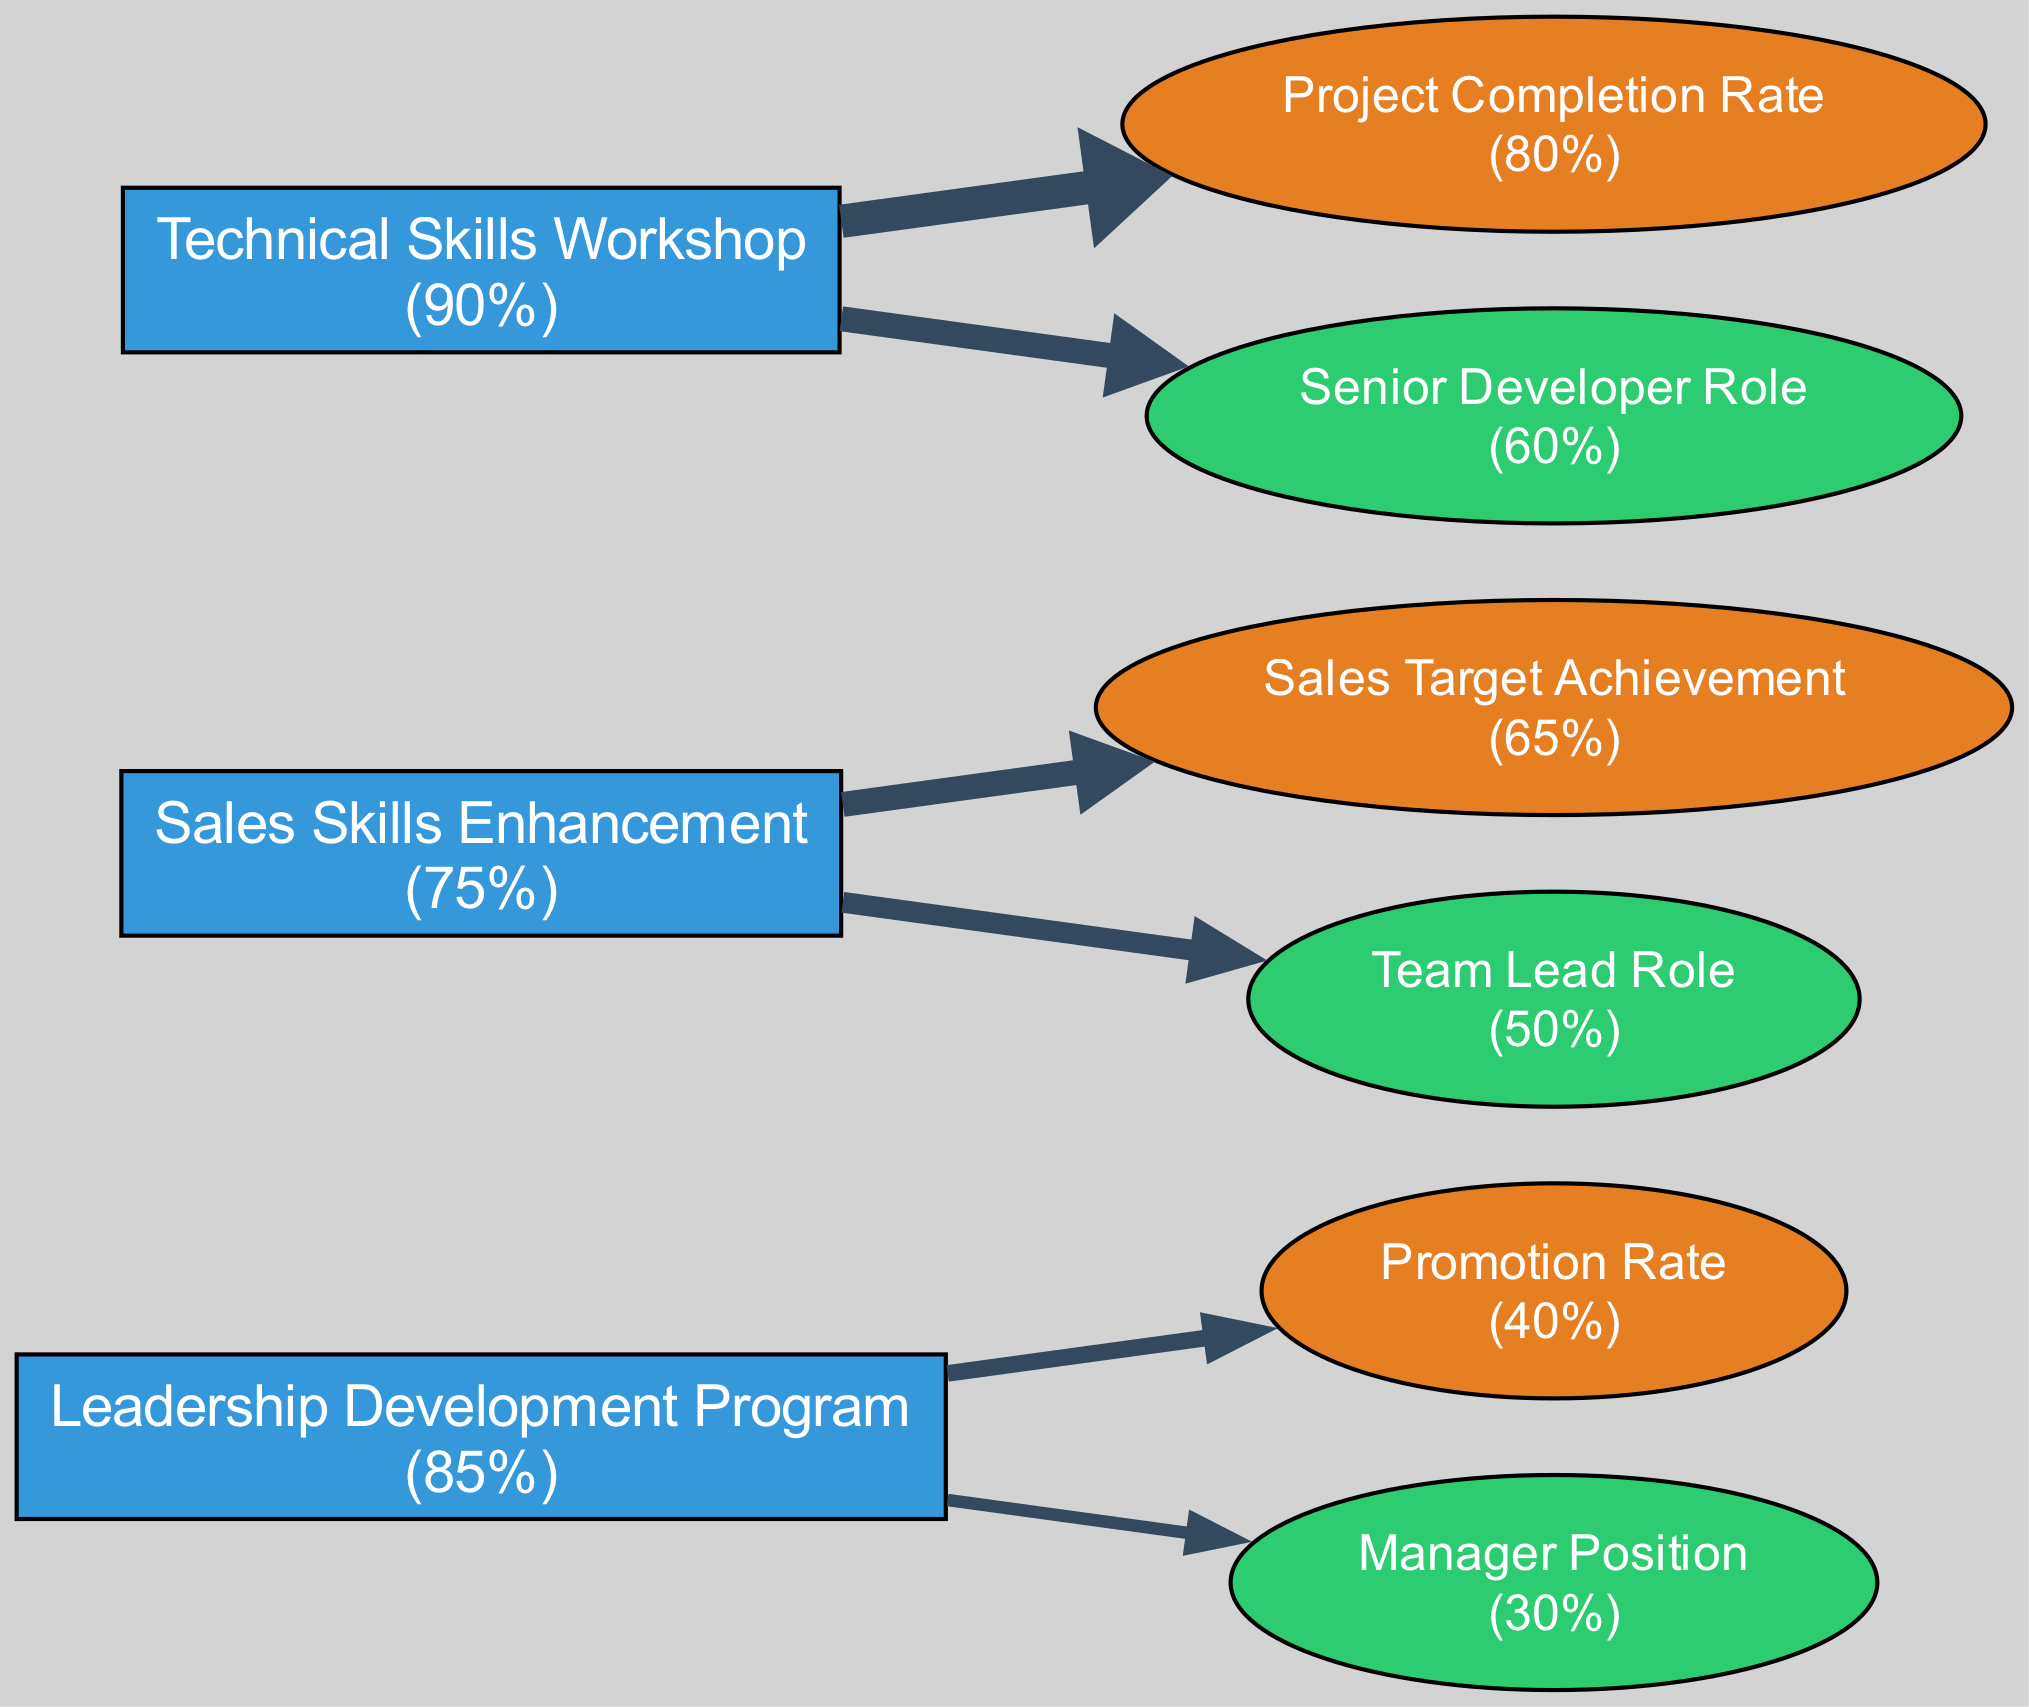What is the completion percentage of the Leadership Development Program? The completion percentage for the Leadership Development Program is indicated within the node, which shows "85%".
Answer: 85% What is the promotion rate achieved by employees who completed the Leadership Development Program? The promotion rate is displayed on the Performance Metrics node that relates to the Leadership Development Program, showing an achievement of "40%".
Answer: 40% How many training programs are shown in the diagram? By counting the nodes labeled as "Training Program", there are three listed in total (Leadership Development Program, Sales Skills Enhancement, and Technical Skills Workshop).
Answer: 3 Which training program is linked to the highest project completion rate? The Technical Skills Workshop has a corresponding Performance Metrics node showing an "80%" achievement for project completion rate, which is higher than the other programs.
Answer: Technical Skills Workshop Which career milestone correlates with the Sales Skills Enhancement program? The Team Lead Role is the Career Milestone that is specifically linked to the Sales Skills Enhancement program, as indicated by the edge connecting these two nodes.
Answer: Team Lead Role What percentage of employees who completed the Technical Skills Workshop achieved the Senior Developer Role? The percentage of employees achieving the Senior Developer Role is stated in the Career Milestone node, which shows an achievement of "60%".
Answer: 60% Which training program has the highest percentage of employees completing it? The Technical Skills Workshop shows the highest completion percentage at "90%" among the training programs.
Answer: 90% Which performance metric shows the lowest achievement percentage among the programs? The Promotion Rate associated with the Leadership Development Program has the lowest achievement at "40%", which is lower than the others shown in the diagram.
Answer: Promotion Rate Which career milestone has the lowest achieved percentage and what is that percentage? The Manager Position is linked to the Leadership Development Program and shows an achievement percentage of "30%", indicating it is the lowest among all milestones.
Answer: 30% 